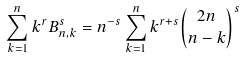Convert formula to latex. <formula><loc_0><loc_0><loc_500><loc_500>\sum _ { k = 1 } ^ { n } k ^ { r } B _ { n , k } ^ { s } = n ^ { - s } \sum _ { k = 1 } ^ { n } k ^ { r + s } { 2 n \choose n - k } ^ { s }</formula> 